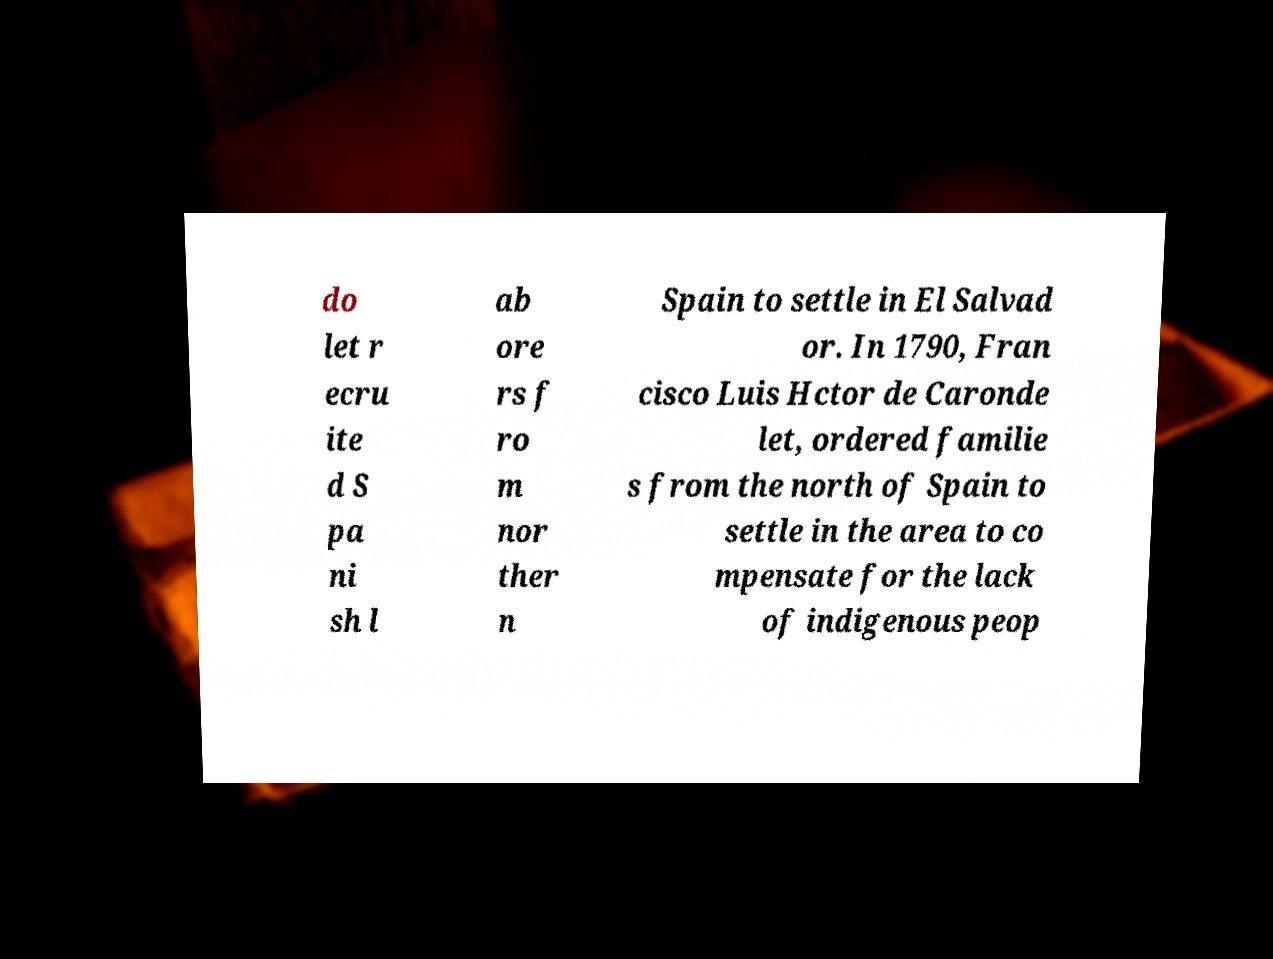What messages or text are displayed in this image? I need them in a readable, typed format. do let r ecru ite d S pa ni sh l ab ore rs f ro m nor ther n Spain to settle in El Salvad or. In 1790, Fran cisco Luis Hctor de Caronde let, ordered familie s from the north of Spain to settle in the area to co mpensate for the lack of indigenous peop 